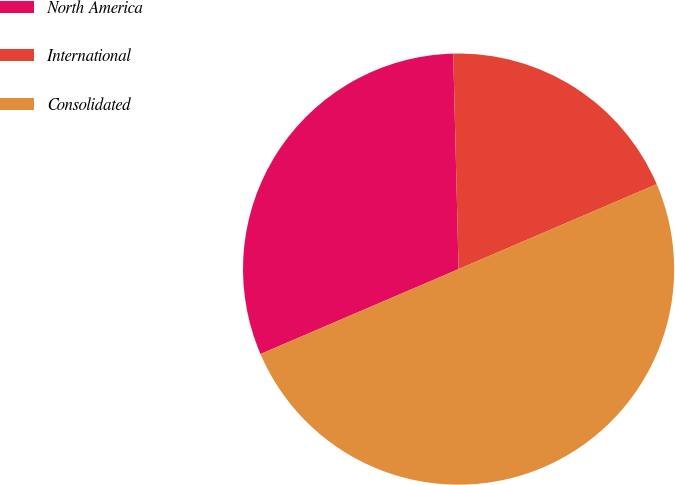Convert chart to OTSL. <chart><loc_0><loc_0><loc_500><loc_500><pie_chart><fcel>North America<fcel>International<fcel>Consolidated<nl><fcel>31.05%<fcel>18.95%<fcel>50.0%<nl></chart> 